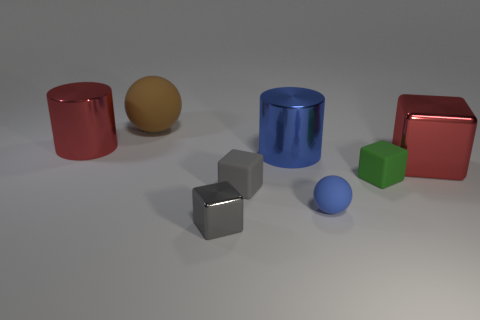What number of shiny things are either cyan cylinders or tiny balls? 0 